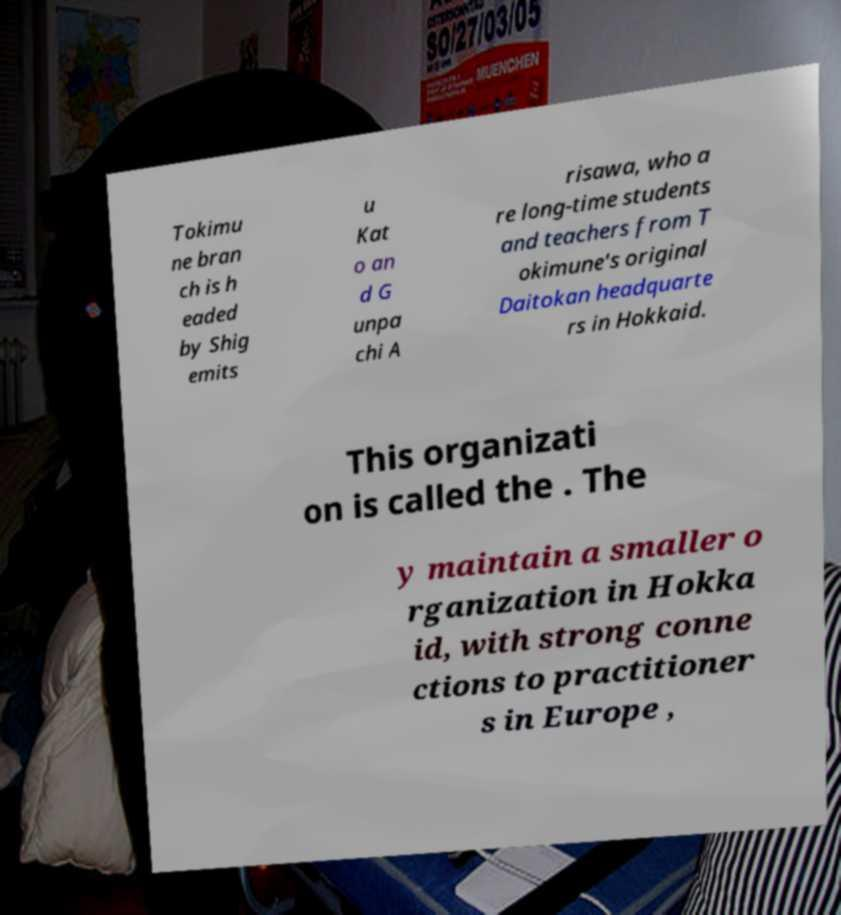There's text embedded in this image that I need extracted. Can you transcribe it verbatim? Tokimu ne bran ch is h eaded by Shig emits u Kat o an d G unpa chi A risawa, who a re long-time students and teachers from T okimune's original Daitokan headquarte rs in Hokkaid. This organizati on is called the . The y maintain a smaller o rganization in Hokka id, with strong conne ctions to practitioner s in Europe , 